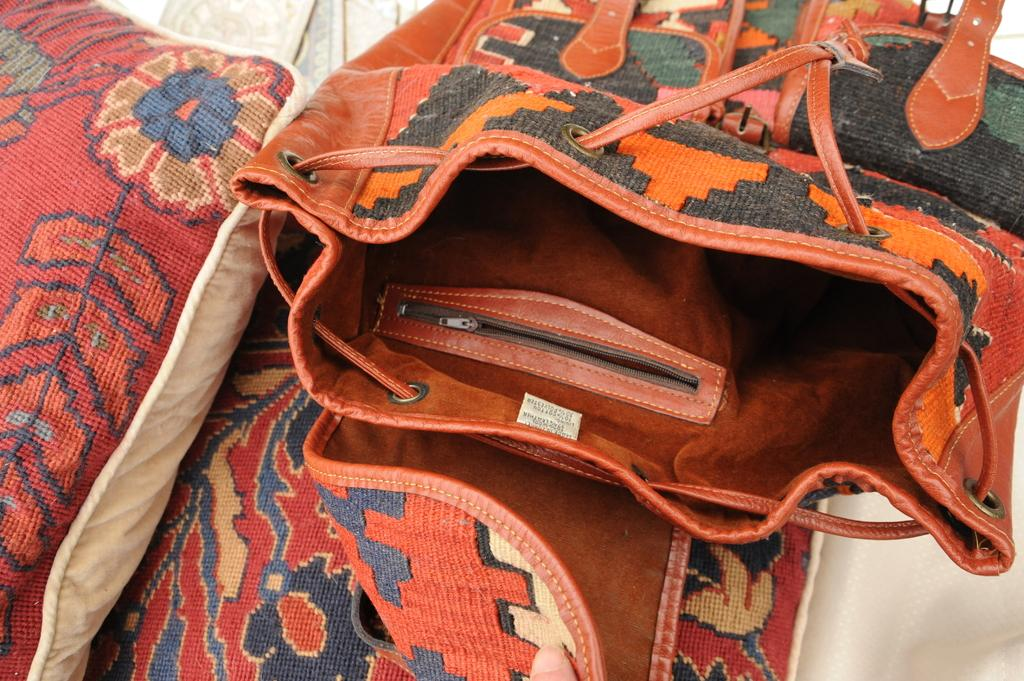What object can be seen in the image? There is a bag in the image. What type of voice can be heard coming from the bag in the image? There is no voice coming from the bag in the image, as it is an inanimate object. 